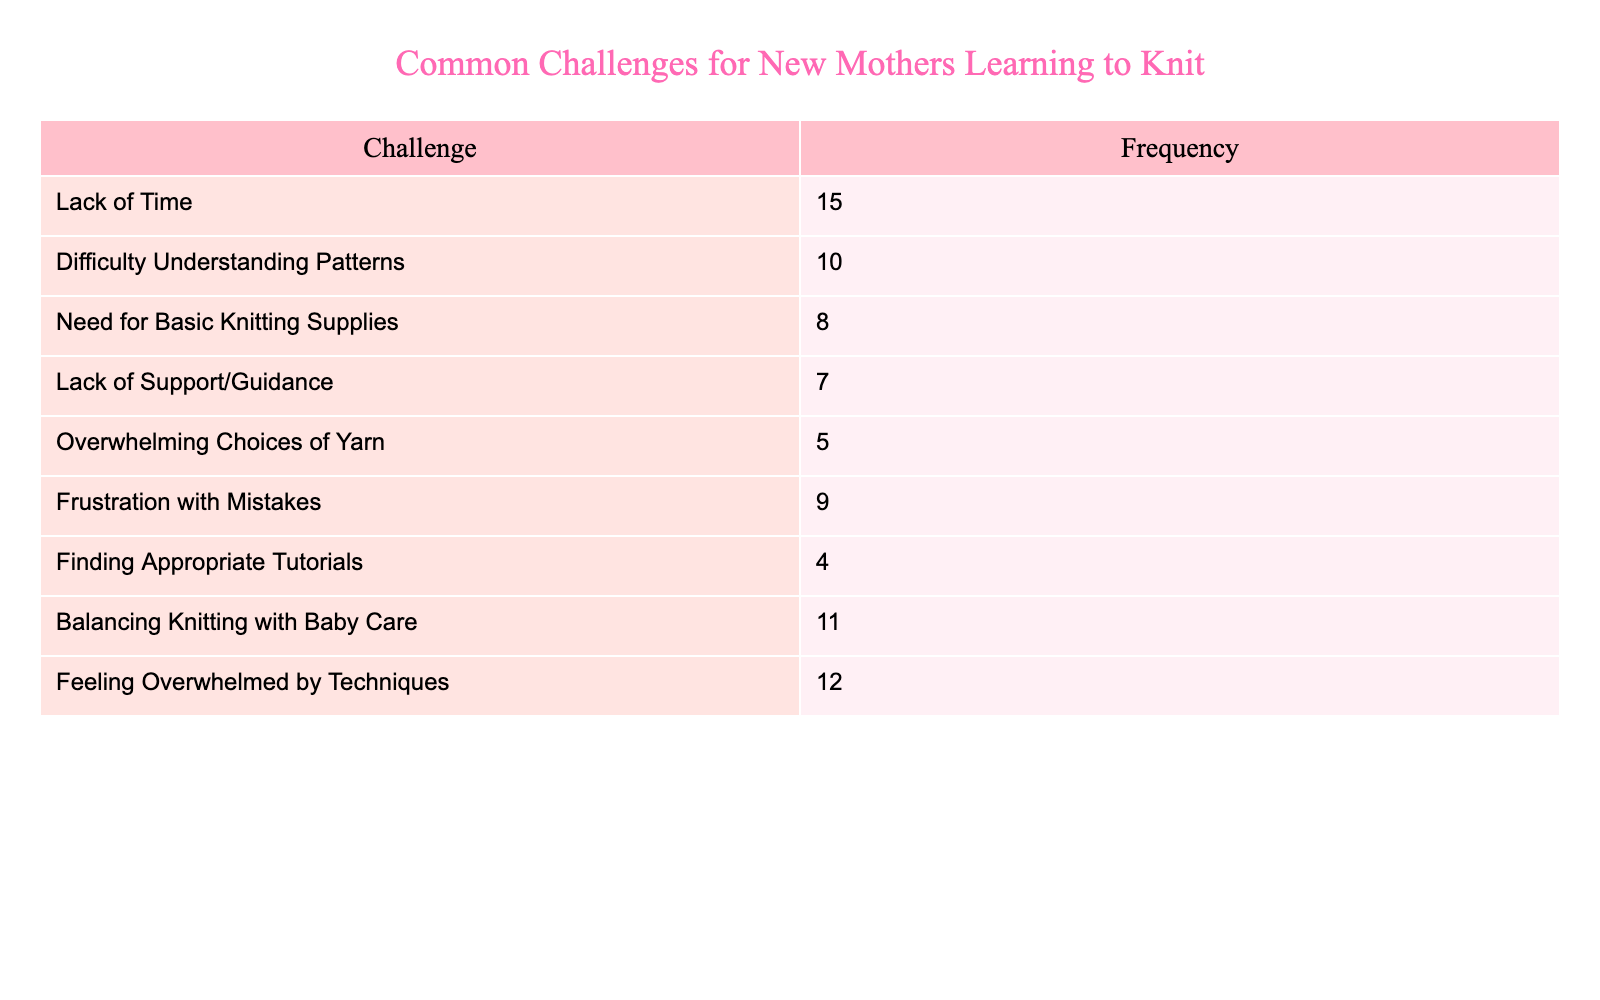What is the most common challenge faced by new mothers while learning to knit? The table lists the challenges and their frequencies. By looking at the frequency column, we see that "Lack of Time" has the highest value of 15, indicating it is the most common challenge.
Answer: Lack of Time How many challenges have a frequency of 10 or more? We look for the challenges that have a frequency of 10 or more in the table. The challenges "Lack of Time" (15), "Balancing Knitting with Baby Care" (11), "Feeling Overwhelmed by Techniques" (12), and "Difficulty Understanding Patterns" (10) meet this criterion. Thus, there are 4 challenges in total.
Answer: 4 What is the total frequency of all challenges listed? To find the total frequency, we need to sum the frequencies of all challenges in the table: 15 + 10 + 8 + 7 + 5 + 9 + 4 + 11 + 12 = 81. Therefore, the total frequency is 81.
Answer: 81 Is “Need for Basic Knitting Supplies” one of the top three challenges? We can refer to the table to see the frequencies: "Lack of Time" (15), "Balancing Knitting with Baby Care" (11), and "Feeling Overwhelmed by Techniques" (12) are the top three challenges. The frequency of "Need for Basic Knitting Supplies" is 8, which is lower than these three. Therefore, it is not in the top three.
Answer: No What is the difference in frequency between the most common and least common challenges? From the table, the frequency of the most common challenge is "Lack of Time" (15), and the least common is "Finding Appropriate Tutorials" (4). The difference is 15 - 4 = 11.
Answer: 11 Which challenge has the same frequency as “Finding Appropriate Tutorials”? Looking through the table, “Finding Appropriate Tutorials” has a frequency of 4. We can see if there are any other challenges that match this frequency. The only challenge with the same frequency of 4 is none; thus, this challenge is unique.
Answer: None 